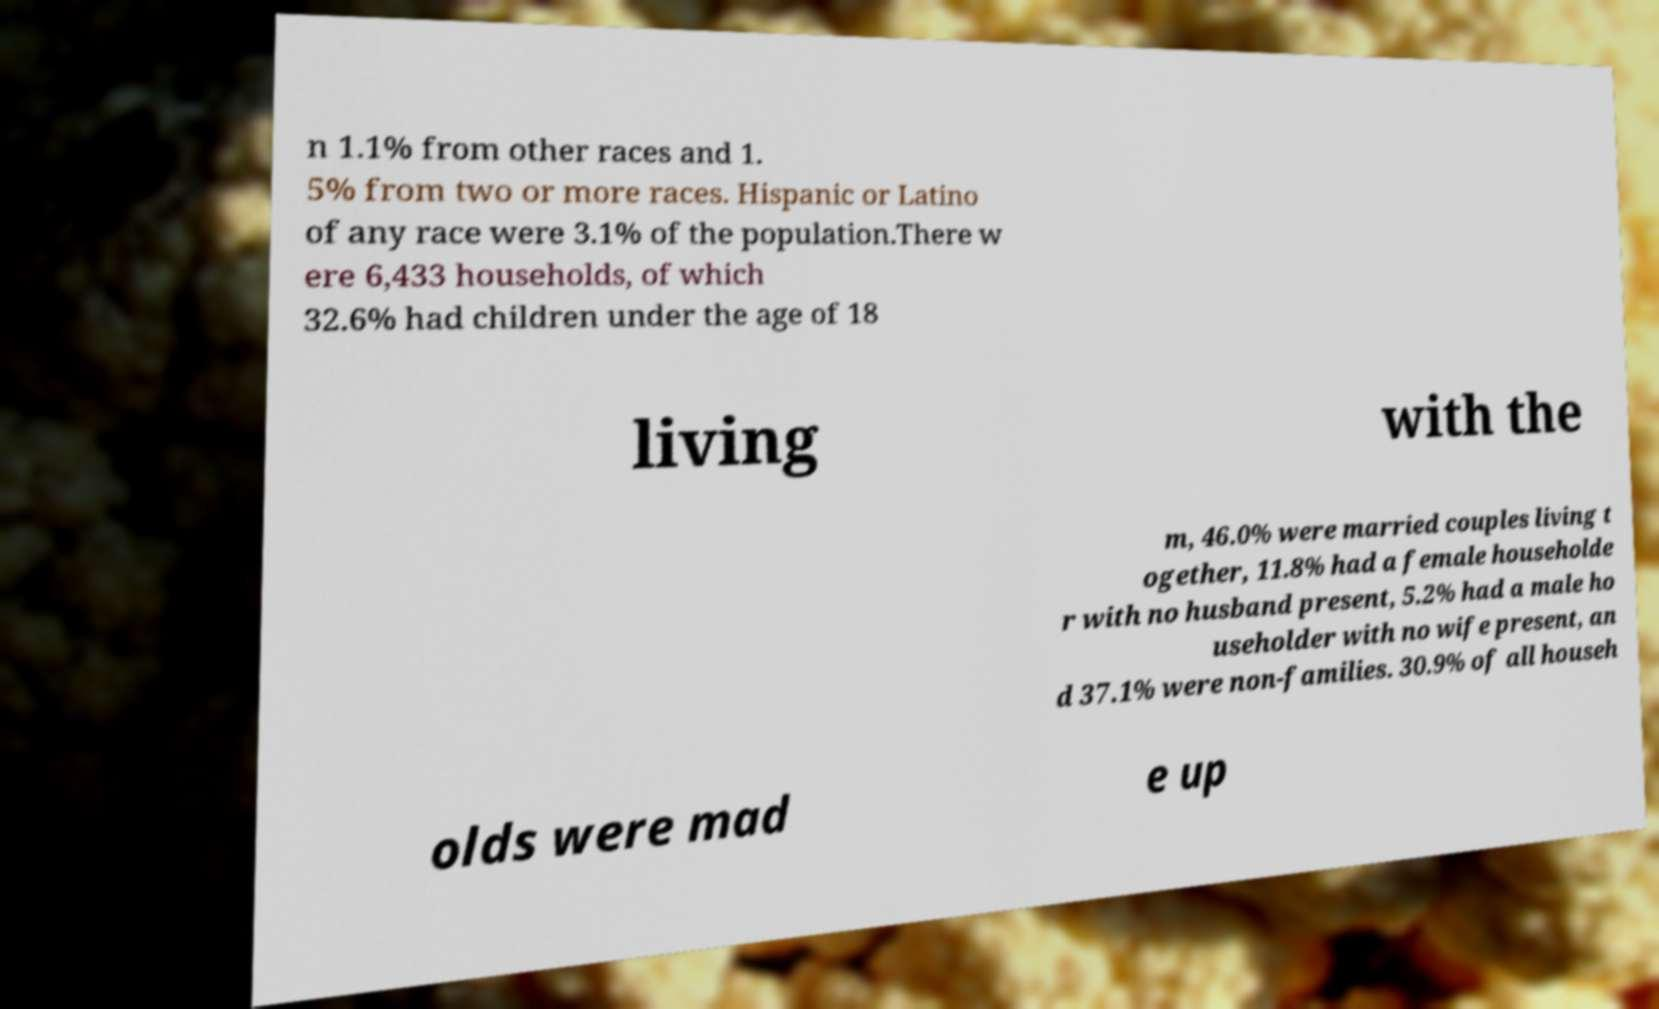Can you accurately transcribe the text from the provided image for me? n 1.1% from other races and 1. 5% from two or more races. Hispanic or Latino of any race were 3.1% of the population.There w ere 6,433 households, of which 32.6% had children under the age of 18 living with the m, 46.0% were married couples living t ogether, 11.8% had a female householde r with no husband present, 5.2% had a male ho useholder with no wife present, an d 37.1% were non-families. 30.9% of all househ olds were mad e up 